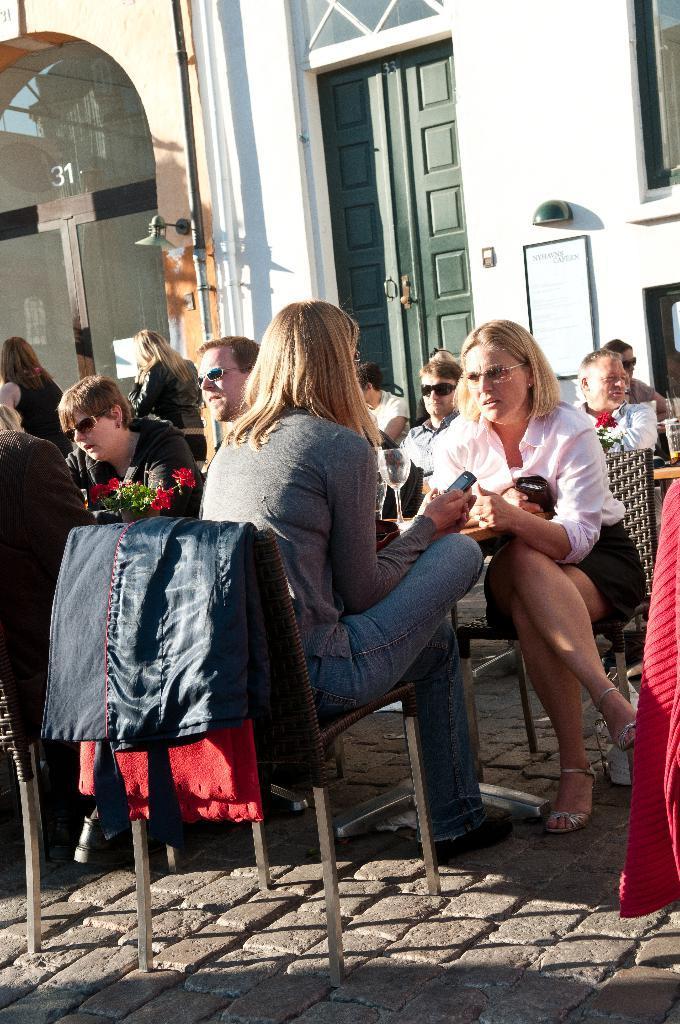How would you summarize this image in a sentence or two? In this picture, we see many people sitting on chair on either side of the table. On table, we see flower vase and glass. Behind them, we see white wall and green door on which whiteboard with text is placed on it. 